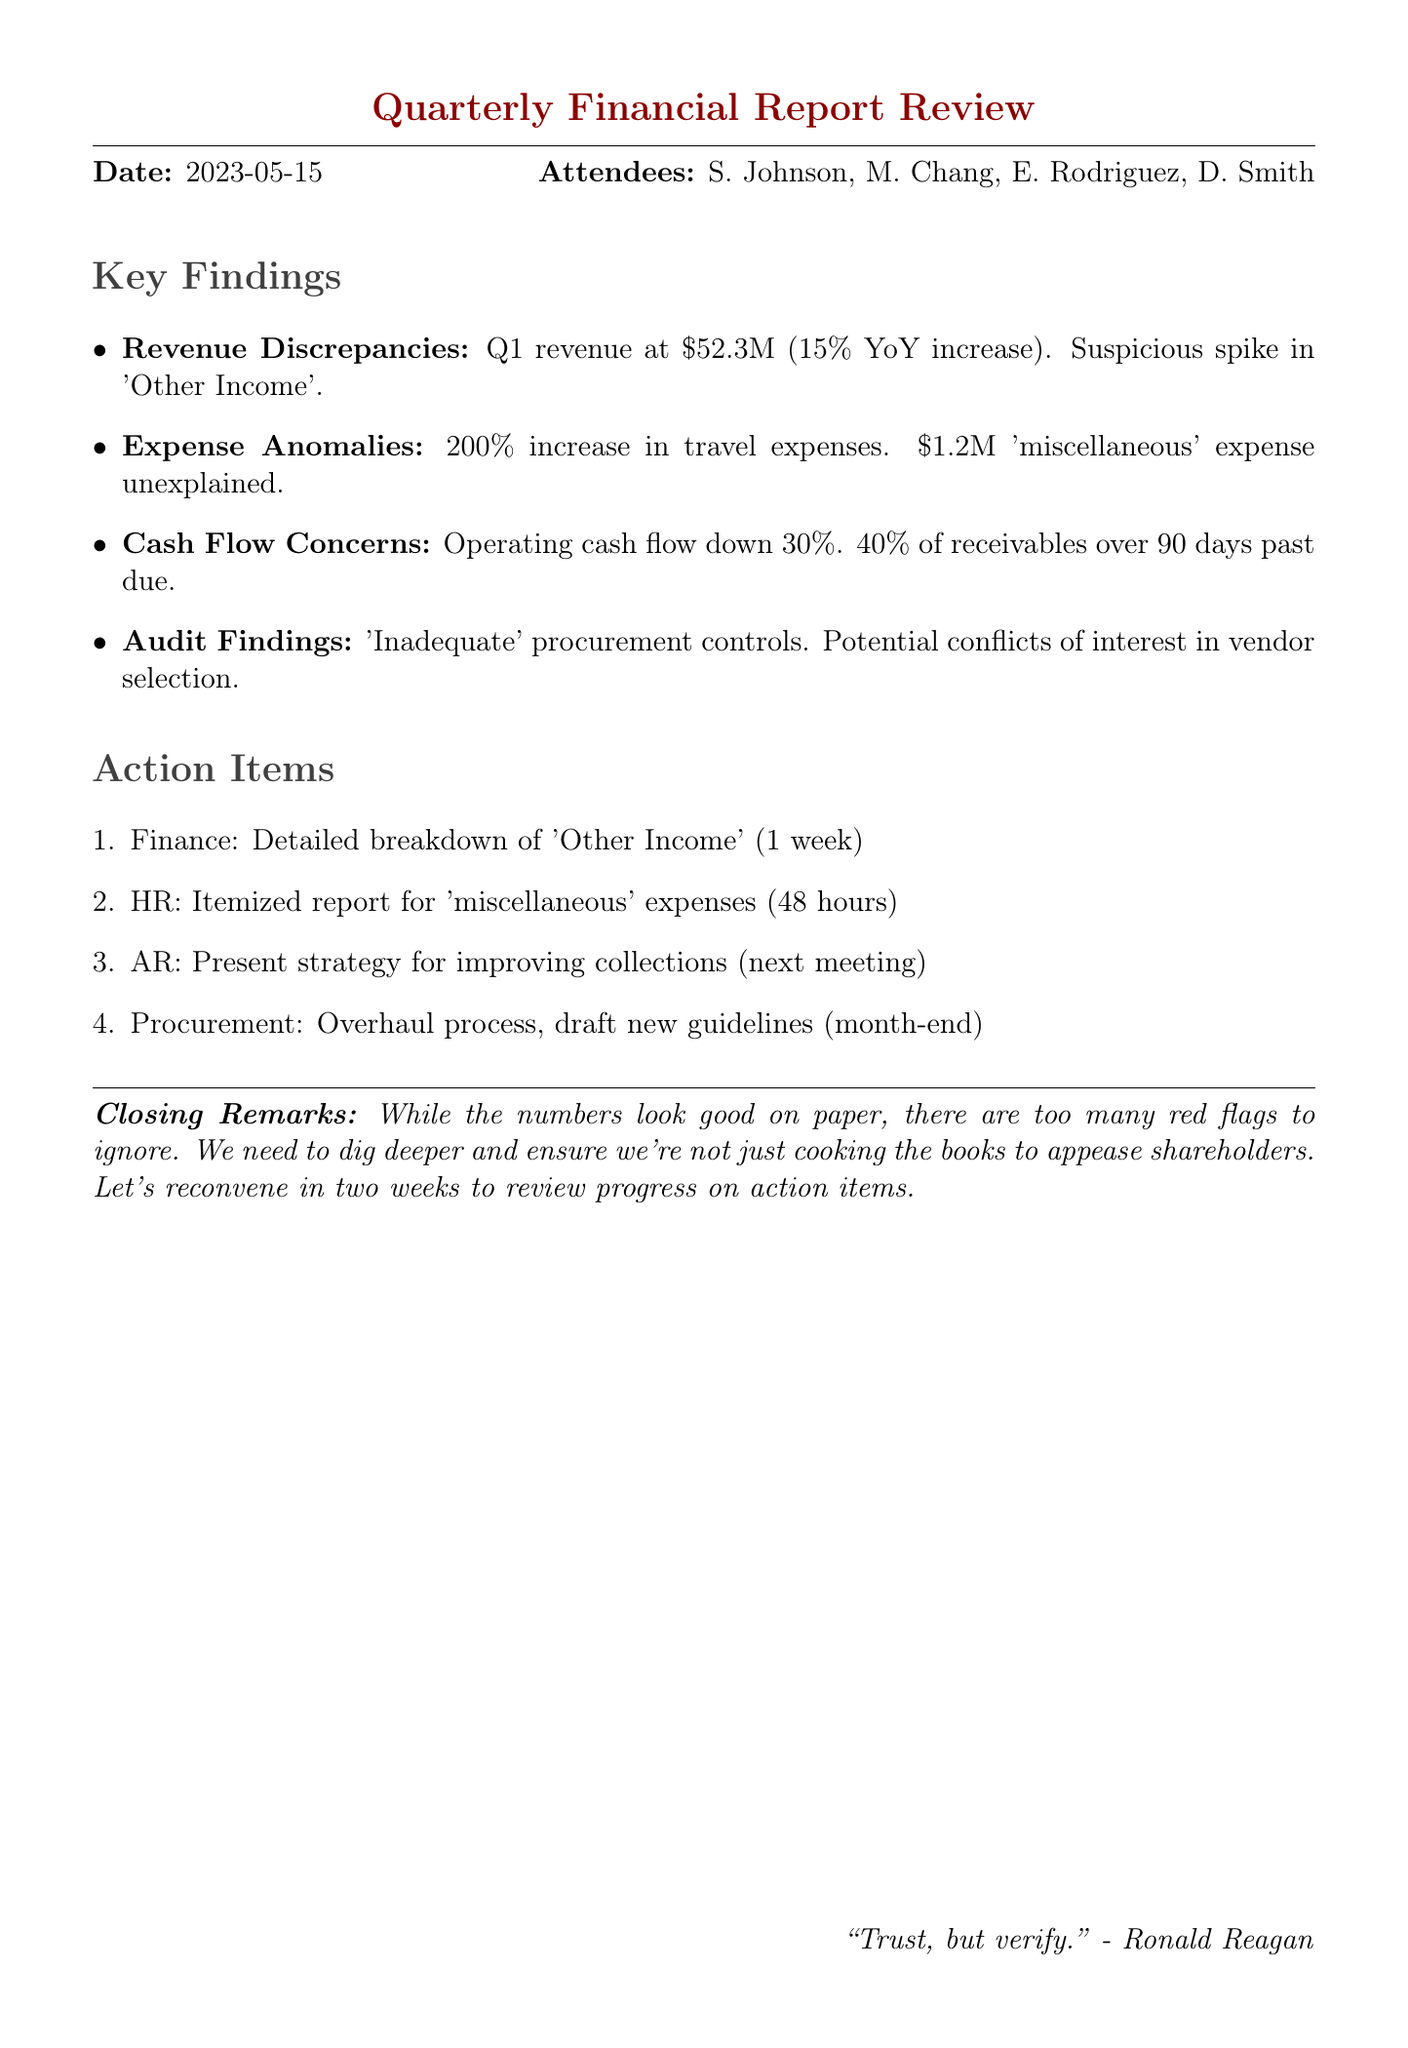What is the date of the meeting? The date of the meeting is specified in the document under the header information.
Answer: 2023-05-15 Who reported the revenue discrepancies? The revenue discrepancies are highlighted in the section where attendees are listed, particularly under the Chief Financial Officer's role.
Answer: Sarah Johnson What percentage increase in revenue was reported? The revenue percentage increase mentioned is found in the details of the revenue discrepancies section.
Answer: 15% What was the amount of the 'miscellaneous' expense entry? The amount of the 'miscellaneous' expense entry is noted under the expense anomalies section discussing high travel costs.
Answer: $1.2M What is the decline percentage of operating cash flow? This percentage appears in the cash flow concerns section and provides insight into financial health.
Answer: 30% How many instances of potential conflict of interest were identified? This information is outlined in the audit findings, summarizing the issues discovered during the review.
Answer: Three What is the timeline for the finance team to provide the breakdown of 'Other Income'? This timeline is detailed in the action items section, indicating deadlines for different teams.
Answer: Next week What action item addresses the procurement process? The details of action items suggest specific changes required to enhance internal controls and vendor selection.
Answer: Overhaul process; draft new guidelines by month-end What does the closing remark suggest about the financial report? The closing remarks provide a critical view of the report's credibility and prompt further scrutiny of the data presented.
Answer: Red flags to ignore 